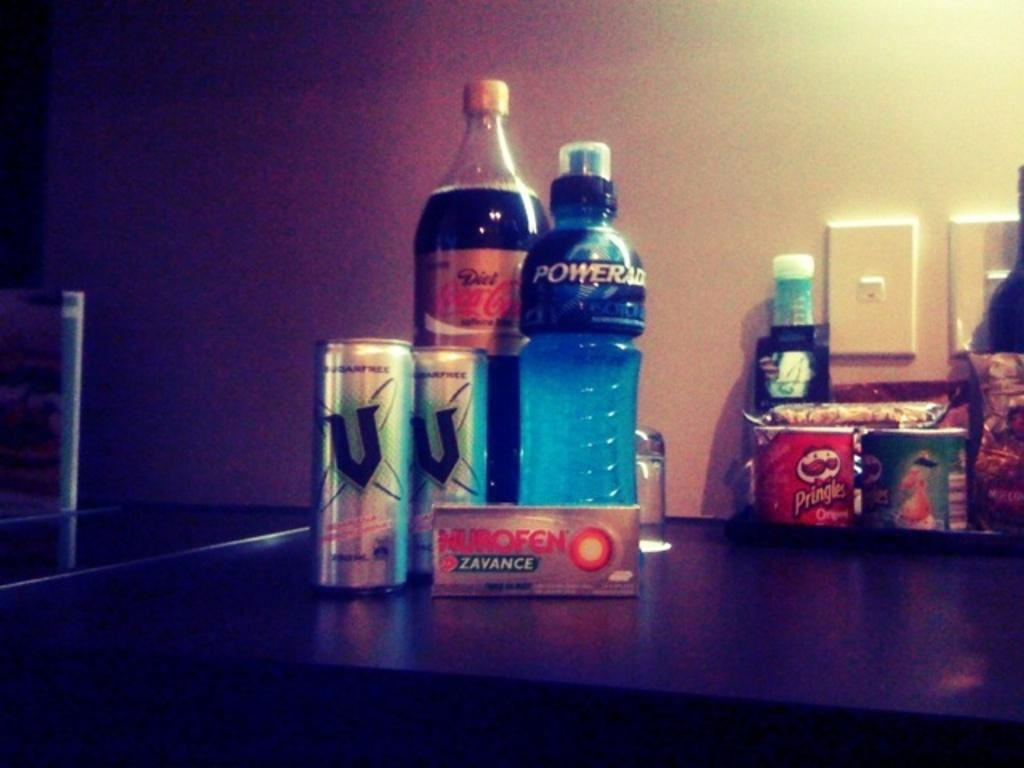Provide a one-sentence caption for the provided image. Some snack food sits on a desk including Powerade, Coca Cola and some Pringles in the background. 